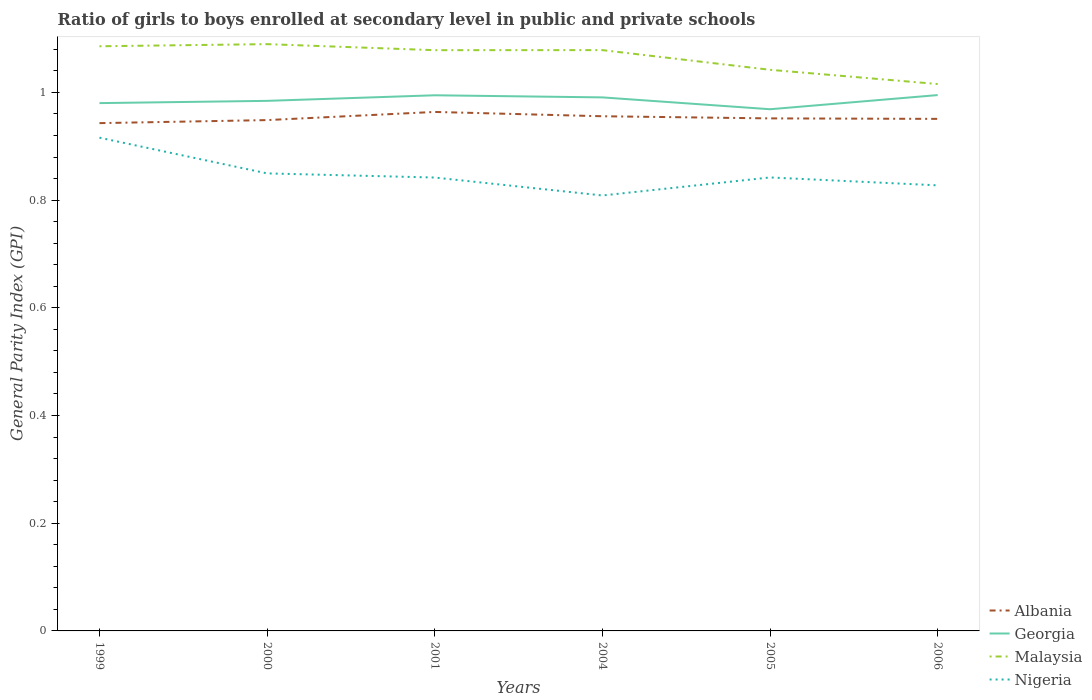Does the line corresponding to Malaysia intersect with the line corresponding to Albania?
Ensure brevity in your answer.  No. Is the number of lines equal to the number of legend labels?
Offer a terse response. Yes. Across all years, what is the maximum general parity index in Albania?
Offer a terse response. 0.94. What is the total general parity index in Georgia in the graph?
Provide a short and direct response. -0.01. What is the difference between the highest and the second highest general parity index in Albania?
Your answer should be very brief. 0.02. What is the difference between the highest and the lowest general parity index in Nigeria?
Keep it short and to the point. 2. What is the difference between two consecutive major ticks on the Y-axis?
Offer a terse response. 0.2. Are the values on the major ticks of Y-axis written in scientific E-notation?
Offer a very short reply. No. Does the graph contain grids?
Offer a very short reply. No. Where does the legend appear in the graph?
Offer a very short reply. Bottom right. How are the legend labels stacked?
Offer a terse response. Vertical. What is the title of the graph?
Provide a short and direct response. Ratio of girls to boys enrolled at secondary level in public and private schools. What is the label or title of the Y-axis?
Ensure brevity in your answer.  General Parity Index (GPI). What is the General Parity Index (GPI) of Albania in 1999?
Ensure brevity in your answer.  0.94. What is the General Parity Index (GPI) in Georgia in 1999?
Give a very brief answer. 0.98. What is the General Parity Index (GPI) of Malaysia in 1999?
Make the answer very short. 1.09. What is the General Parity Index (GPI) of Nigeria in 1999?
Ensure brevity in your answer.  0.92. What is the General Parity Index (GPI) of Albania in 2000?
Give a very brief answer. 0.95. What is the General Parity Index (GPI) of Georgia in 2000?
Offer a terse response. 0.98. What is the General Parity Index (GPI) of Malaysia in 2000?
Keep it short and to the point. 1.09. What is the General Parity Index (GPI) in Nigeria in 2000?
Offer a very short reply. 0.85. What is the General Parity Index (GPI) of Albania in 2001?
Provide a short and direct response. 0.96. What is the General Parity Index (GPI) in Georgia in 2001?
Your response must be concise. 0.99. What is the General Parity Index (GPI) in Malaysia in 2001?
Your answer should be compact. 1.08. What is the General Parity Index (GPI) in Nigeria in 2001?
Your answer should be very brief. 0.84. What is the General Parity Index (GPI) in Albania in 2004?
Give a very brief answer. 0.96. What is the General Parity Index (GPI) in Georgia in 2004?
Offer a very short reply. 0.99. What is the General Parity Index (GPI) in Malaysia in 2004?
Keep it short and to the point. 1.08. What is the General Parity Index (GPI) in Nigeria in 2004?
Offer a very short reply. 0.81. What is the General Parity Index (GPI) of Albania in 2005?
Your answer should be compact. 0.95. What is the General Parity Index (GPI) in Georgia in 2005?
Your answer should be compact. 0.97. What is the General Parity Index (GPI) of Malaysia in 2005?
Offer a very short reply. 1.04. What is the General Parity Index (GPI) in Nigeria in 2005?
Your response must be concise. 0.84. What is the General Parity Index (GPI) of Albania in 2006?
Provide a short and direct response. 0.95. What is the General Parity Index (GPI) of Georgia in 2006?
Offer a terse response. 1. What is the General Parity Index (GPI) of Malaysia in 2006?
Your response must be concise. 1.02. What is the General Parity Index (GPI) of Nigeria in 2006?
Provide a succinct answer. 0.83. Across all years, what is the maximum General Parity Index (GPI) in Albania?
Offer a very short reply. 0.96. Across all years, what is the maximum General Parity Index (GPI) of Georgia?
Keep it short and to the point. 1. Across all years, what is the maximum General Parity Index (GPI) of Malaysia?
Keep it short and to the point. 1.09. Across all years, what is the maximum General Parity Index (GPI) of Nigeria?
Your answer should be very brief. 0.92. Across all years, what is the minimum General Parity Index (GPI) of Albania?
Your response must be concise. 0.94. Across all years, what is the minimum General Parity Index (GPI) in Georgia?
Keep it short and to the point. 0.97. Across all years, what is the minimum General Parity Index (GPI) in Malaysia?
Provide a short and direct response. 1.02. Across all years, what is the minimum General Parity Index (GPI) in Nigeria?
Your answer should be compact. 0.81. What is the total General Parity Index (GPI) in Albania in the graph?
Your response must be concise. 5.71. What is the total General Parity Index (GPI) in Georgia in the graph?
Your response must be concise. 5.91. What is the total General Parity Index (GPI) of Malaysia in the graph?
Your answer should be compact. 6.39. What is the total General Parity Index (GPI) in Nigeria in the graph?
Provide a succinct answer. 5.09. What is the difference between the General Parity Index (GPI) of Albania in 1999 and that in 2000?
Keep it short and to the point. -0.01. What is the difference between the General Parity Index (GPI) of Georgia in 1999 and that in 2000?
Make the answer very short. -0. What is the difference between the General Parity Index (GPI) of Malaysia in 1999 and that in 2000?
Provide a short and direct response. -0. What is the difference between the General Parity Index (GPI) in Nigeria in 1999 and that in 2000?
Ensure brevity in your answer.  0.07. What is the difference between the General Parity Index (GPI) of Albania in 1999 and that in 2001?
Offer a very short reply. -0.02. What is the difference between the General Parity Index (GPI) of Georgia in 1999 and that in 2001?
Keep it short and to the point. -0.01. What is the difference between the General Parity Index (GPI) of Malaysia in 1999 and that in 2001?
Offer a terse response. 0.01. What is the difference between the General Parity Index (GPI) of Nigeria in 1999 and that in 2001?
Your answer should be compact. 0.07. What is the difference between the General Parity Index (GPI) in Albania in 1999 and that in 2004?
Make the answer very short. -0.01. What is the difference between the General Parity Index (GPI) in Georgia in 1999 and that in 2004?
Your answer should be very brief. -0.01. What is the difference between the General Parity Index (GPI) in Malaysia in 1999 and that in 2004?
Keep it short and to the point. 0.01. What is the difference between the General Parity Index (GPI) in Nigeria in 1999 and that in 2004?
Offer a very short reply. 0.11. What is the difference between the General Parity Index (GPI) in Albania in 1999 and that in 2005?
Make the answer very short. -0.01. What is the difference between the General Parity Index (GPI) in Georgia in 1999 and that in 2005?
Give a very brief answer. 0.01. What is the difference between the General Parity Index (GPI) in Malaysia in 1999 and that in 2005?
Your answer should be compact. 0.04. What is the difference between the General Parity Index (GPI) in Nigeria in 1999 and that in 2005?
Provide a short and direct response. 0.07. What is the difference between the General Parity Index (GPI) in Albania in 1999 and that in 2006?
Ensure brevity in your answer.  -0.01. What is the difference between the General Parity Index (GPI) in Georgia in 1999 and that in 2006?
Keep it short and to the point. -0.01. What is the difference between the General Parity Index (GPI) in Malaysia in 1999 and that in 2006?
Your answer should be compact. 0.07. What is the difference between the General Parity Index (GPI) in Nigeria in 1999 and that in 2006?
Your answer should be very brief. 0.09. What is the difference between the General Parity Index (GPI) in Albania in 2000 and that in 2001?
Offer a very short reply. -0.02. What is the difference between the General Parity Index (GPI) in Georgia in 2000 and that in 2001?
Offer a very short reply. -0.01. What is the difference between the General Parity Index (GPI) of Malaysia in 2000 and that in 2001?
Your answer should be compact. 0.01. What is the difference between the General Parity Index (GPI) in Nigeria in 2000 and that in 2001?
Offer a very short reply. 0.01. What is the difference between the General Parity Index (GPI) in Albania in 2000 and that in 2004?
Give a very brief answer. -0.01. What is the difference between the General Parity Index (GPI) of Georgia in 2000 and that in 2004?
Provide a short and direct response. -0.01. What is the difference between the General Parity Index (GPI) in Malaysia in 2000 and that in 2004?
Your answer should be very brief. 0.01. What is the difference between the General Parity Index (GPI) of Nigeria in 2000 and that in 2004?
Provide a succinct answer. 0.04. What is the difference between the General Parity Index (GPI) in Albania in 2000 and that in 2005?
Your answer should be very brief. -0. What is the difference between the General Parity Index (GPI) in Georgia in 2000 and that in 2005?
Offer a very short reply. 0.02. What is the difference between the General Parity Index (GPI) of Malaysia in 2000 and that in 2005?
Your answer should be very brief. 0.05. What is the difference between the General Parity Index (GPI) in Nigeria in 2000 and that in 2005?
Make the answer very short. 0.01. What is the difference between the General Parity Index (GPI) of Albania in 2000 and that in 2006?
Ensure brevity in your answer.  -0. What is the difference between the General Parity Index (GPI) of Georgia in 2000 and that in 2006?
Give a very brief answer. -0.01. What is the difference between the General Parity Index (GPI) of Malaysia in 2000 and that in 2006?
Offer a very short reply. 0.07. What is the difference between the General Parity Index (GPI) of Nigeria in 2000 and that in 2006?
Provide a short and direct response. 0.02. What is the difference between the General Parity Index (GPI) of Albania in 2001 and that in 2004?
Your answer should be compact. 0.01. What is the difference between the General Parity Index (GPI) in Georgia in 2001 and that in 2004?
Provide a succinct answer. 0. What is the difference between the General Parity Index (GPI) of Malaysia in 2001 and that in 2004?
Your answer should be very brief. -0. What is the difference between the General Parity Index (GPI) of Albania in 2001 and that in 2005?
Provide a short and direct response. 0.01. What is the difference between the General Parity Index (GPI) in Georgia in 2001 and that in 2005?
Give a very brief answer. 0.03. What is the difference between the General Parity Index (GPI) in Malaysia in 2001 and that in 2005?
Provide a short and direct response. 0.04. What is the difference between the General Parity Index (GPI) of Nigeria in 2001 and that in 2005?
Ensure brevity in your answer.  -0. What is the difference between the General Parity Index (GPI) in Albania in 2001 and that in 2006?
Provide a short and direct response. 0.01. What is the difference between the General Parity Index (GPI) in Georgia in 2001 and that in 2006?
Provide a succinct answer. -0. What is the difference between the General Parity Index (GPI) in Malaysia in 2001 and that in 2006?
Give a very brief answer. 0.06. What is the difference between the General Parity Index (GPI) in Nigeria in 2001 and that in 2006?
Provide a succinct answer. 0.01. What is the difference between the General Parity Index (GPI) of Albania in 2004 and that in 2005?
Offer a very short reply. 0. What is the difference between the General Parity Index (GPI) of Georgia in 2004 and that in 2005?
Keep it short and to the point. 0.02. What is the difference between the General Parity Index (GPI) of Malaysia in 2004 and that in 2005?
Make the answer very short. 0.04. What is the difference between the General Parity Index (GPI) in Nigeria in 2004 and that in 2005?
Your answer should be very brief. -0.03. What is the difference between the General Parity Index (GPI) of Albania in 2004 and that in 2006?
Your answer should be compact. 0. What is the difference between the General Parity Index (GPI) in Georgia in 2004 and that in 2006?
Your response must be concise. -0. What is the difference between the General Parity Index (GPI) in Malaysia in 2004 and that in 2006?
Your answer should be compact. 0.06. What is the difference between the General Parity Index (GPI) of Nigeria in 2004 and that in 2006?
Your answer should be very brief. -0.02. What is the difference between the General Parity Index (GPI) in Albania in 2005 and that in 2006?
Ensure brevity in your answer.  0. What is the difference between the General Parity Index (GPI) in Georgia in 2005 and that in 2006?
Ensure brevity in your answer.  -0.03. What is the difference between the General Parity Index (GPI) in Malaysia in 2005 and that in 2006?
Your answer should be very brief. 0.03. What is the difference between the General Parity Index (GPI) of Nigeria in 2005 and that in 2006?
Offer a very short reply. 0.01. What is the difference between the General Parity Index (GPI) of Albania in 1999 and the General Parity Index (GPI) of Georgia in 2000?
Ensure brevity in your answer.  -0.04. What is the difference between the General Parity Index (GPI) in Albania in 1999 and the General Parity Index (GPI) in Malaysia in 2000?
Give a very brief answer. -0.15. What is the difference between the General Parity Index (GPI) in Albania in 1999 and the General Parity Index (GPI) in Nigeria in 2000?
Provide a short and direct response. 0.09. What is the difference between the General Parity Index (GPI) of Georgia in 1999 and the General Parity Index (GPI) of Malaysia in 2000?
Ensure brevity in your answer.  -0.11. What is the difference between the General Parity Index (GPI) in Georgia in 1999 and the General Parity Index (GPI) in Nigeria in 2000?
Make the answer very short. 0.13. What is the difference between the General Parity Index (GPI) of Malaysia in 1999 and the General Parity Index (GPI) of Nigeria in 2000?
Ensure brevity in your answer.  0.24. What is the difference between the General Parity Index (GPI) in Albania in 1999 and the General Parity Index (GPI) in Georgia in 2001?
Your response must be concise. -0.05. What is the difference between the General Parity Index (GPI) of Albania in 1999 and the General Parity Index (GPI) of Malaysia in 2001?
Provide a short and direct response. -0.14. What is the difference between the General Parity Index (GPI) in Albania in 1999 and the General Parity Index (GPI) in Nigeria in 2001?
Ensure brevity in your answer.  0.1. What is the difference between the General Parity Index (GPI) in Georgia in 1999 and the General Parity Index (GPI) in Malaysia in 2001?
Make the answer very short. -0.1. What is the difference between the General Parity Index (GPI) in Georgia in 1999 and the General Parity Index (GPI) in Nigeria in 2001?
Offer a terse response. 0.14. What is the difference between the General Parity Index (GPI) in Malaysia in 1999 and the General Parity Index (GPI) in Nigeria in 2001?
Offer a very short reply. 0.24. What is the difference between the General Parity Index (GPI) of Albania in 1999 and the General Parity Index (GPI) of Georgia in 2004?
Offer a terse response. -0.05. What is the difference between the General Parity Index (GPI) of Albania in 1999 and the General Parity Index (GPI) of Malaysia in 2004?
Keep it short and to the point. -0.14. What is the difference between the General Parity Index (GPI) in Albania in 1999 and the General Parity Index (GPI) in Nigeria in 2004?
Ensure brevity in your answer.  0.13. What is the difference between the General Parity Index (GPI) of Georgia in 1999 and the General Parity Index (GPI) of Malaysia in 2004?
Your response must be concise. -0.1. What is the difference between the General Parity Index (GPI) of Georgia in 1999 and the General Parity Index (GPI) of Nigeria in 2004?
Provide a succinct answer. 0.17. What is the difference between the General Parity Index (GPI) of Malaysia in 1999 and the General Parity Index (GPI) of Nigeria in 2004?
Your answer should be compact. 0.28. What is the difference between the General Parity Index (GPI) in Albania in 1999 and the General Parity Index (GPI) in Georgia in 2005?
Provide a short and direct response. -0.03. What is the difference between the General Parity Index (GPI) of Albania in 1999 and the General Parity Index (GPI) of Malaysia in 2005?
Offer a very short reply. -0.1. What is the difference between the General Parity Index (GPI) in Albania in 1999 and the General Parity Index (GPI) in Nigeria in 2005?
Your response must be concise. 0.1. What is the difference between the General Parity Index (GPI) in Georgia in 1999 and the General Parity Index (GPI) in Malaysia in 2005?
Offer a terse response. -0.06. What is the difference between the General Parity Index (GPI) of Georgia in 1999 and the General Parity Index (GPI) of Nigeria in 2005?
Keep it short and to the point. 0.14. What is the difference between the General Parity Index (GPI) of Malaysia in 1999 and the General Parity Index (GPI) of Nigeria in 2005?
Give a very brief answer. 0.24. What is the difference between the General Parity Index (GPI) in Albania in 1999 and the General Parity Index (GPI) in Georgia in 2006?
Your response must be concise. -0.05. What is the difference between the General Parity Index (GPI) in Albania in 1999 and the General Parity Index (GPI) in Malaysia in 2006?
Ensure brevity in your answer.  -0.07. What is the difference between the General Parity Index (GPI) of Albania in 1999 and the General Parity Index (GPI) of Nigeria in 2006?
Make the answer very short. 0.12. What is the difference between the General Parity Index (GPI) of Georgia in 1999 and the General Parity Index (GPI) of Malaysia in 2006?
Keep it short and to the point. -0.04. What is the difference between the General Parity Index (GPI) in Georgia in 1999 and the General Parity Index (GPI) in Nigeria in 2006?
Keep it short and to the point. 0.15. What is the difference between the General Parity Index (GPI) of Malaysia in 1999 and the General Parity Index (GPI) of Nigeria in 2006?
Offer a very short reply. 0.26. What is the difference between the General Parity Index (GPI) in Albania in 2000 and the General Parity Index (GPI) in Georgia in 2001?
Ensure brevity in your answer.  -0.05. What is the difference between the General Parity Index (GPI) in Albania in 2000 and the General Parity Index (GPI) in Malaysia in 2001?
Give a very brief answer. -0.13. What is the difference between the General Parity Index (GPI) of Albania in 2000 and the General Parity Index (GPI) of Nigeria in 2001?
Keep it short and to the point. 0.11. What is the difference between the General Parity Index (GPI) of Georgia in 2000 and the General Parity Index (GPI) of Malaysia in 2001?
Offer a terse response. -0.09. What is the difference between the General Parity Index (GPI) in Georgia in 2000 and the General Parity Index (GPI) in Nigeria in 2001?
Make the answer very short. 0.14. What is the difference between the General Parity Index (GPI) of Malaysia in 2000 and the General Parity Index (GPI) of Nigeria in 2001?
Offer a terse response. 0.25. What is the difference between the General Parity Index (GPI) of Albania in 2000 and the General Parity Index (GPI) of Georgia in 2004?
Give a very brief answer. -0.04. What is the difference between the General Parity Index (GPI) of Albania in 2000 and the General Parity Index (GPI) of Malaysia in 2004?
Provide a short and direct response. -0.13. What is the difference between the General Parity Index (GPI) in Albania in 2000 and the General Parity Index (GPI) in Nigeria in 2004?
Your answer should be compact. 0.14. What is the difference between the General Parity Index (GPI) in Georgia in 2000 and the General Parity Index (GPI) in Malaysia in 2004?
Provide a succinct answer. -0.09. What is the difference between the General Parity Index (GPI) in Georgia in 2000 and the General Parity Index (GPI) in Nigeria in 2004?
Offer a very short reply. 0.18. What is the difference between the General Parity Index (GPI) in Malaysia in 2000 and the General Parity Index (GPI) in Nigeria in 2004?
Make the answer very short. 0.28. What is the difference between the General Parity Index (GPI) of Albania in 2000 and the General Parity Index (GPI) of Georgia in 2005?
Offer a very short reply. -0.02. What is the difference between the General Parity Index (GPI) in Albania in 2000 and the General Parity Index (GPI) in Malaysia in 2005?
Make the answer very short. -0.09. What is the difference between the General Parity Index (GPI) in Albania in 2000 and the General Parity Index (GPI) in Nigeria in 2005?
Give a very brief answer. 0.11. What is the difference between the General Parity Index (GPI) of Georgia in 2000 and the General Parity Index (GPI) of Malaysia in 2005?
Ensure brevity in your answer.  -0.06. What is the difference between the General Parity Index (GPI) in Georgia in 2000 and the General Parity Index (GPI) in Nigeria in 2005?
Ensure brevity in your answer.  0.14. What is the difference between the General Parity Index (GPI) in Malaysia in 2000 and the General Parity Index (GPI) in Nigeria in 2005?
Give a very brief answer. 0.25. What is the difference between the General Parity Index (GPI) of Albania in 2000 and the General Parity Index (GPI) of Georgia in 2006?
Keep it short and to the point. -0.05. What is the difference between the General Parity Index (GPI) of Albania in 2000 and the General Parity Index (GPI) of Malaysia in 2006?
Provide a succinct answer. -0.07. What is the difference between the General Parity Index (GPI) in Albania in 2000 and the General Parity Index (GPI) in Nigeria in 2006?
Your response must be concise. 0.12. What is the difference between the General Parity Index (GPI) of Georgia in 2000 and the General Parity Index (GPI) of Malaysia in 2006?
Offer a very short reply. -0.03. What is the difference between the General Parity Index (GPI) of Georgia in 2000 and the General Parity Index (GPI) of Nigeria in 2006?
Your answer should be compact. 0.16. What is the difference between the General Parity Index (GPI) of Malaysia in 2000 and the General Parity Index (GPI) of Nigeria in 2006?
Offer a terse response. 0.26. What is the difference between the General Parity Index (GPI) of Albania in 2001 and the General Parity Index (GPI) of Georgia in 2004?
Give a very brief answer. -0.03. What is the difference between the General Parity Index (GPI) in Albania in 2001 and the General Parity Index (GPI) in Malaysia in 2004?
Keep it short and to the point. -0.11. What is the difference between the General Parity Index (GPI) of Albania in 2001 and the General Parity Index (GPI) of Nigeria in 2004?
Keep it short and to the point. 0.16. What is the difference between the General Parity Index (GPI) of Georgia in 2001 and the General Parity Index (GPI) of Malaysia in 2004?
Keep it short and to the point. -0.08. What is the difference between the General Parity Index (GPI) in Georgia in 2001 and the General Parity Index (GPI) in Nigeria in 2004?
Offer a very short reply. 0.19. What is the difference between the General Parity Index (GPI) in Malaysia in 2001 and the General Parity Index (GPI) in Nigeria in 2004?
Your response must be concise. 0.27. What is the difference between the General Parity Index (GPI) of Albania in 2001 and the General Parity Index (GPI) of Georgia in 2005?
Provide a succinct answer. -0.01. What is the difference between the General Parity Index (GPI) in Albania in 2001 and the General Parity Index (GPI) in Malaysia in 2005?
Keep it short and to the point. -0.08. What is the difference between the General Parity Index (GPI) of Albania in 2001 and the General Parity Index (GPI) of Nigeria in 2005?
Keep it short and to the point. 0.12. What is the difference between the General Parity Index (GPI) in Georgia in 2001 and the General Parity Index (GPI) in Malaysia in 2005?
Offer a very short reply. -0.05. What is the difference between the General Parity Index (GPI) of Georgia in 2001 and the General Parity Index (GPI) of Nigeria in 2005?
Offer a very short reply. 0.15. What is the difference between the General Parity Index (GPI) in Malaysia in 2001 and the General Parity Index (GPI) in Nigeria in 2005?
Provide a succinct answer. 0.24. What is the difference between the General Parity Index (GPI) in Albania in 2001 and the General Parity Index (GPI) in Georgia in 2006?
Ensure brevity in your answer.  -0.03. What is the difference between the General Parity Index (GPI) of Albania in 2001 and the General Parity Index (GPI) of Malaysia in 2006?
Offer a very short reply. -0.05. What is the difference between the General Parity Index (GPI) of Albania in 2001 and the General Parity Index (GPI) of Nigeria in 2006?
Offer a terse response. 0.14. What is the difference between the General Parity Index (GPI) of Georgia in 2001 and the General Parity Index (GPI) of Malaysia in 2006?
Your answer should be very brief. -0.02. What is the difference between the General Parity Index (GPI) of Georgia in 2001 and the General Parity Index (GPI) of Nigeria in 2006?
Provide a succinct answer. 0.17. What is the difference between the General Parity Index (GPI) in Malaysia in 2001 and the General Parity Index (GPI) in Nigeria in 2006?
Your response must be concise. 0.25. What is the difference between the General Parity Index (GPI) in Albania in 2004 and the General Parity Index (GPI) in Georgia in 2005?
Your answer should be very brief. -0.01. What is the difference between the General Parity Index (GPI) in Albania in 2004 and the General Parity Index (GPI) in Malaysia in 2005?
Your answer should be compact. -0.09. What is the difference between the General Parity Index (GPI) in Albania in 2004 and the General Parity Index (GPI) in Nigeria in 2005?
Keep it short and to the point. 0.11. What is the difference between the General Parity Index (GPI) in Georgia in 2004 and the General Parity Index (GPI) in Malaysia in 2005?
Provide a succinct answer. -0.05. What is the difference between the General Parity Index (GPI) of Georgia in 2004 and the General Parity Index (GPI) of Nigeria in 2005?
Your response must be concise. 0.15. What is the difference between the General Parity Index (GPI) of Malaysia in 2004 and the General Parity Index (GPI) of Nigeria in 2005?
Offer a terse response. 0.24. What is the difference between the General Parity Index (GPI) in Albania in 2004 and the General Parity Index (GPI) in Georgia in 2006?
Offer a very short reply. -0.04. What is the difference between the General Parity Index (GPI) of Albania in 2004 and the General Parity Index (GPI) of Malaysia in 2006?
Make the answer very short. -0.06. What is the difference between the General Parity Index (GPI) in Albania in 2004 and the General Parity Index (GPI) in Nigeria in 2006?
Ensure brevity in your answer.  0.13. What is the difference between the General Parity Index (GPI) in Georgia in 2004 and the General Parity Index (GPI) in Malaysia in 2006?
Ensure brevity in your answer.  -0.02. What is the difference between the General Parity Index (GPI) of Georgia in 2004 and the General Parity Index (GPI) of Nigeria in 2006?
Give a very brief answer. 0.16. What is the difference between the General Parity Index (GPI) of Malaysia in 2004 and the General Parity Index (GPI) of Nigeria in 2006?
Offer a terse response. 0.25. What is the difference between the General Parity Index (GPI) of Albania in 2005 and the General Parity Index (GPI) of Georgia in 2006?
Offer a very short reply. -0.04. What is the difference between the General Parity Index (GPI) of Albania in 2005 and the General Parity Index (GPI) of Malaysia in 2006?
Keep it short and to the point. -0.06. What is the difference between the General Parity Index (GPI) in Albania in 2005 and the General Parity Index (GPI) in Nigeria in 2006?
Give a very brief answer. 0.12. What is the difference between the General Parity Index (GPI) of Georgia in 2005 and the General Parity Index (GPI) of Malaysia in 2006?
Keep it short and to the point. -0.05. What is the difference between the General Parity Index (GPI) of Georgia in 2005 and the General Parity Index (GPI) of Nigeria in 2006?
Make the answer very short. 0.14. What is the difference between the General Parity Index (GPI) of Malaysia in 2005 and the General Parity Index (GPI) of Nigeria in 2006?
Your response must be concise. 0.21. What is the average General Parity Index (GPI) in Albania per year?
Make the answer very short. 0.95. What is the average General Parity Index (GPI) of Georgia per year?
Provide a succinct answer. 0.99. What is the average General Parity Index (GPI) in Malaysia per year?
Keep it short and to the point. 1.06. What is the average General Parity Index (GPI) in Nigeria per year?
Keep it short and to the point. 0.85. In the year 1999, what is the difference between the General Parity Index (GPI) in Albania and General Parity Index (GPI) in Georgia?
Offer a terse response. -0.04. In the year 1999, what is the difference between the General Parity Index (GPI) of Albania and General Parity Index (GPI) of Malaysia?
Your response must be concise. -0.14. In the year 1999, what is the difference between the General Parity Index (GPI) of Albania and General Parity Index (GPI) of Nigeria?
Make the answer very short. 0.03. In the year 1999, what is the difference between the General Parity Index (GPI) of Georgia and General Parity Index (GPI) of Malaysia?
Your answer should be very brief. -0.11. In the year 1999, what is the difference between the General Parity Index (GPI) of Georgia and General Parity Index (GPI) of Nigeria?
Make the answer very short. 0.06. In the year 1999, what is the difference between the General Parity Index (GPI) in Malaysia and General Parity Index (GPI) in Nigeria?
Offer a terse response. 0.17. In the year 2000, what is the difference between the General Parity Index (GPI) of Albania and General Parity Index (GPI) of Georgia?
Ensure brevity in your answer.  -0.04. In the year 2000, what is the difference between the General Parity Index (GPI) of Albania and General Parity Index (GPI) of Malaysia?
Offer a terse response. -0.14. In the year 2000, what is the difference between the General Parity Index (GPI) of Albania and General Parity Index (GPI) of Nigeria?
Keep it short and to the point. 0.1. In the year 2000, what is the difference between the General Parity Index (GPI) in Georgia and General Parity Index (GPI) in Malaysia?
Your answer should be compact. -0.11. In the year 2000, what is the difference between the General Parity Index (GPI) of Georgia and General Parity Index (GPI) of Nigeria?
Your response must be concise. 0.13. In the year 2000, what is the difference between the General Parity Index (GPI) of Malaysia and General Parity Index (GPI) of Nigeria?
Your answer should be very brief. 0.24. In the year 2001, what is the difference between the General Parity Index (GPI) of Albania and General Parity Index (GPI) of Georgia?
Provide a short and direct response. -0.03. In the year 2001, what is the difference between the General Parity Index (GPI) of Albania and General Parity Index (GPI) of Malaysia?
Your response must be concise. -0.11. In the year 2001, what is the difference between the General Parity Index (GPI) of Albania and General Parity Index (GPI) of Nigeria?
Offer a terse response. 0.12. In the year 2001, what is the difference between the General Parity Index (GPI) in Georgia and General Parity Index (GPI) in Malaysia?
Make the answer very short. -0.08. In the year 2001, what is the difference between the General Parity Index (GPI) of Georgia and General Parity Index (GPI) of Nigeria?
Provide a succinct answer. 0.15. In the year 2001, what is the difference between the General Parity Index (GPI) of Malaysia and General Parity Index (GPI) of Nigeria?
Keep it short and to the point. 0.24. In the year 2004, what is the difference between the General Parity Index (GPI) of Albania and General Parity Index (GPI) of Georgia?
Offer a very short reply. -0.04. In the year 2004, what is the difference between the General Parity Index (GPI) in Albania and General Parity Index (GPI) in Malaysia?
Your answer should be very brief. -0.12. In the year 2004, what is the difference between the General Parity Index (GPI) of Albania and General Parity Index (GPI) of Nigeria?
Keep it short and to the point. 0.15. In the year 2004, what is the difference between the General Parity Index (GPI) of Georgia and General Parity Index (GPI) of Malaysia?
Provide a succinct answer. -0.09. In the year 2004, what is the difference between the General Parity Index (GPI) of Georgia and General Parity Index (GPI) of Nigeria?
Your answer should be very brief. 0.18. In the year 2004, what is the difference between the General Parity Index (GPI) of Malaysia and General Parity Index (GPI) of Nigeria?
Offer a very short reply. 0.27. In the year 2005, what is the difference between the General Parity Index (GPI) of Albania and General Parity Index (GPI) of Georgia?
Make the answer very short. -0.02. In the year 2005, what is the difference between the General Parity Index (GPI) in Albania and General Parity Index (GPI) in Malaysia?
Your response must be concise. -0.09. In the year 2005, what is the difference between the General Parity Index (GPI) of Albania and General Parity Index (GPI) of Nigeria?
Ensure brevity in your answer.  0.11. In the year 2005, what is the difference between the General Parity Index (GPI) in Georgia and General Parity Index (GPI) in Malaysia?
Give a very brief answer. -0.07. In the year 2005, what is the difference between the General Parity Index (GPI) in Georgia and General Parity Index (GPI) in Nigeria?
Your response must be concise. 0.13. In the year 2005, what is the difference between the General Parity Index (GPI) in Malaysia and General Parity Index (GPI) in Nigeria?
Your response must be concise. 0.2. In the year 2006, what is the difference between the General Parity Index (GPI) of Albania and General Parity Index (GPI) of Georgia?
Ensure brevity in your answer.  -0.04. In the year 2006, what is the difference between the General Parity Index (GPI) of Albania and General Parity Index (GPI) of Malaysia?
Your response must be concise. -0.06. In the year 2006, what is the difference between the General Parity Index (GPI) of Albania and General Parity Index (GPI) of Nigeria?
Provide a short and direct response. 0.12. In the year 2006, what is the difference between the General Parity Index (GPI) in Georgia and General Parity Index (GPI) in Malaysia?
Ensure brevity in your answer.  -0.02. In the year 2006, what is the difference between the General Parity Index (GPI) in Georgia and General Parity Index (GPI) in Nigeria?
Provide a short and direct response. 0.17. In the year 2006, what is the difference between the General Parity Index (GPI) in Malaysia and General Parity Index (GPI) in Nigeria?
Provide a succinct answer. 0.19. What is the ratio of the General Parity Index (GPI) in Malaysia in 1999 to that in 2000?
Offer a terse response. 1. What is the ratio of the General Parity Index (GPI) in Nigeria in 1999 to that in 2000?
Give a very brief answer. 1.08. What is the ratio of the General Parity Index (GPI) in Albania in 1999 to that in 2001?
Offer a terse response. 0.98. What is the ratio of the General Parity Index (GPI) in Georgia in 1999 to that in 2001?
Your response must be concise. 0.99. What is the ratio of the General Parity Index (GPI) of Malaysia in 1999 to that in 2001?
Keep it short and to the point. 1.01. What is the ratio of the General Parity Index (GPI) in Nigeria in 1999 to that in 2001?
Offer a very short reply. 1.09. What is the ratio of the General Parity Index (GPI) in Albania in 1999 to that in 2004?
Your response must be concise. 0.99. What is the ratio of the General Parity Index (GPI) in Georgia in 1999 to that in 2004?
Ensure brevity in your answer.  0.99. What is the ratio of the General Parity Index (GPI) of Malaysia in 1999 to that in 2004?
Offer a terse response. 1.01. What is the ratio of the General Parity Index (GPI) of Nigeria in 1999 to that in 2004?
Provide a short and direct response. 1.13. What is the ratio of the General Parity Index (GPI) in Georgia in 1999 to that in 2005?
Provide a short and direct response. 1.01. What is the ratio of the General Parity Index (GPI) of Malaysia in 1999 to that in 2005?
Ensure brevity in your answer.  1.04. What is the ratio of the General Parity Index (GPI) of Nigeria in 1999 to that in 2005?
Make the answer very short. 1.09. What is the ratio of the General Parity Index (GPI) of Albania in 1999 to that in 2006?
Your answer should be very brief. 0.99. What is the ratio of the General Parity Index (GPI) in Malaysia in 1999 to that in 2006?
Offer a very short reply. 1.07. What is the ratio of the General Parity Index (GPI) in Nigeria in 1999 to that in 2006?
Make the answer very short. 1.11. What is the ratio of the General Parity Index (GPI) in Albania in 2000 to that in 2001?
Keep it short and to the point. 0.98. What is the ratio of the General Parity Index (GPI) of Malaysia in 2000 to that in 2001?
Provide a short and direct response. 1.01. What is the ratio of the General Parity Index (GPI) of Nigeria in 2000 to that in 2001?
Your answer should be compact. 1.01. What is the ratio of the General Parity Index (GPI) of Malaysia in 2000 to that in 2004?
Offer a terse response. 1.01. What is the ratio of the General Parity Index (GPI) in Nigeria in 2000 to that in 2004?
Your answer should be very brief. 1.05. What is the ratio of the General Parity Index (GPI) in Albania in 2000 to that in 2005?
Give a very brief answer. 1. What is the ratio of the General Parity Index (GPI) of Georgia in 2000 to that in 2005?
Make the answer very short. 1.02. What is the ratio of the General Parity Index (GPI) in Malaysia in 2000 to that in 2005?
Offer a very short reply. 1.05. What is the ratio of the General Parity Index (GPI) in Nigeria in 2000 to that in 2005?
Offer a very short reply. 1.01. What is the ratio of the General Parity Index (GPI) in Georgia in 2000 to that in 2006?
Provide a short and direct response. 0.99. What is the ratio of the General Parity Index (GPI) in Malaysia in 2000 to that in 2006?
Keep it short and to the point. 1.07. What is the ratio of the General Parity Index (GPI) in Nigeria in 2000 to that in 2006?
Your answer should be very brief. 1.03. What is the ratio of the General Parity Index (GPI) of Albania in 2001 to that in 2004?
Give a very brief answer. 1.01. What is the ratio of the General Parity Index (GPI) of Nigeria in 2001 to that in 2004?
Your answer should be compact. 1.04. What is the ratio of the General Parity Index (GPI) in Albania in 2001 to that in 2005?
Make the answer very short. 1.01. What is the ratio of the General Parity Index (GPI) of Georgia in 2001 to that in 2005?
Make the answer very short. 1.03. What is the ratio of the General Parity Index (GPI) of Malaysia in 2001 to that in 2005?
Offer a terse response. 1.03. What is the ratio of the General Parity Index (GPI) in Albania in 2001 to that in 2006?
Your response must be concise. 1.01. What is the ratio of the General Parity Index (GPI) in Malaysia in 2001 to that in 2006?
Your answer should be very brief. 1.06. What is the ratio of the General Parity Index (GPI) of Nigeria in 2001 to that in 2006?
Your response must be concise. 1.02. What is the ratio of the General Parity Index (GPI) of Georgia in 2004 to that in 2005?
Your answer should be very brief. 1.02. What is the ratio of the General Parity Index (GPI) of Malaysia in 2004 to that in 2005?
Provide a succinct answer. 1.04. What is the ratio of the General Parity Index (GPI) in Nigeria in 2004 to that in 2005?
Your answer should be compact. 0.96. What is the ratio of the General Parity Index (GPI) of Albania in 2004 to that in 2006?
Your answer should be very brief. 1.01. What is the ratio of the General Parity Index (GPI) in Malaysia in 2004 to that in 2006?
Ensure brevity in your answer.  1.06. What is the ratio of the General Parity Index (GPI) in Nigeria in 2004 to that in 2006?
Your answer should be compact. 0.98. What is the ratio of the General Parity Index (GPI) of Georgia in 2005 to that in 2006?
Ensure brevity in your answer.  0.97. What is the ratio of the General Parity Index (GPI) in Malaysia in 2005 to that in 2006?
Your answer should be very brief. 1.03. What is the ratio of the General Parity Index (GPI) in Nigeria in 2005 to that in 2006?
Keep it short and to the point. 1.02. What is the difference between the highest and the second highest General Parity Index (GPI) of Albania?
Provide a succinct answer. 0.01. What is the difference between the highest and the second highest General Parity Index (GPI) in Malaysia?
Make the answer very short. 0. What is the difference between the highest and the second highest General Parity Index (GPI) in Nigeria?
Provide a succinct answer. 0.07. What is the difference between the highest and the lowest General Parity Index (GPI) of Albania?
Your answer should be compact. 0.02. What is the difference between the highest and the lowest General Parity Index (GPI) in Georgia?
Your response must be concise. 0.03. What is the difference between the highest and the lowest General Parity Index (GPI) in Malaysia?
Keep it short and to the point. 0.07. What is the difference between the highest and the lowest General Parity Index (GPI) of Nigeria?
Your response must be concise. 0.11. 